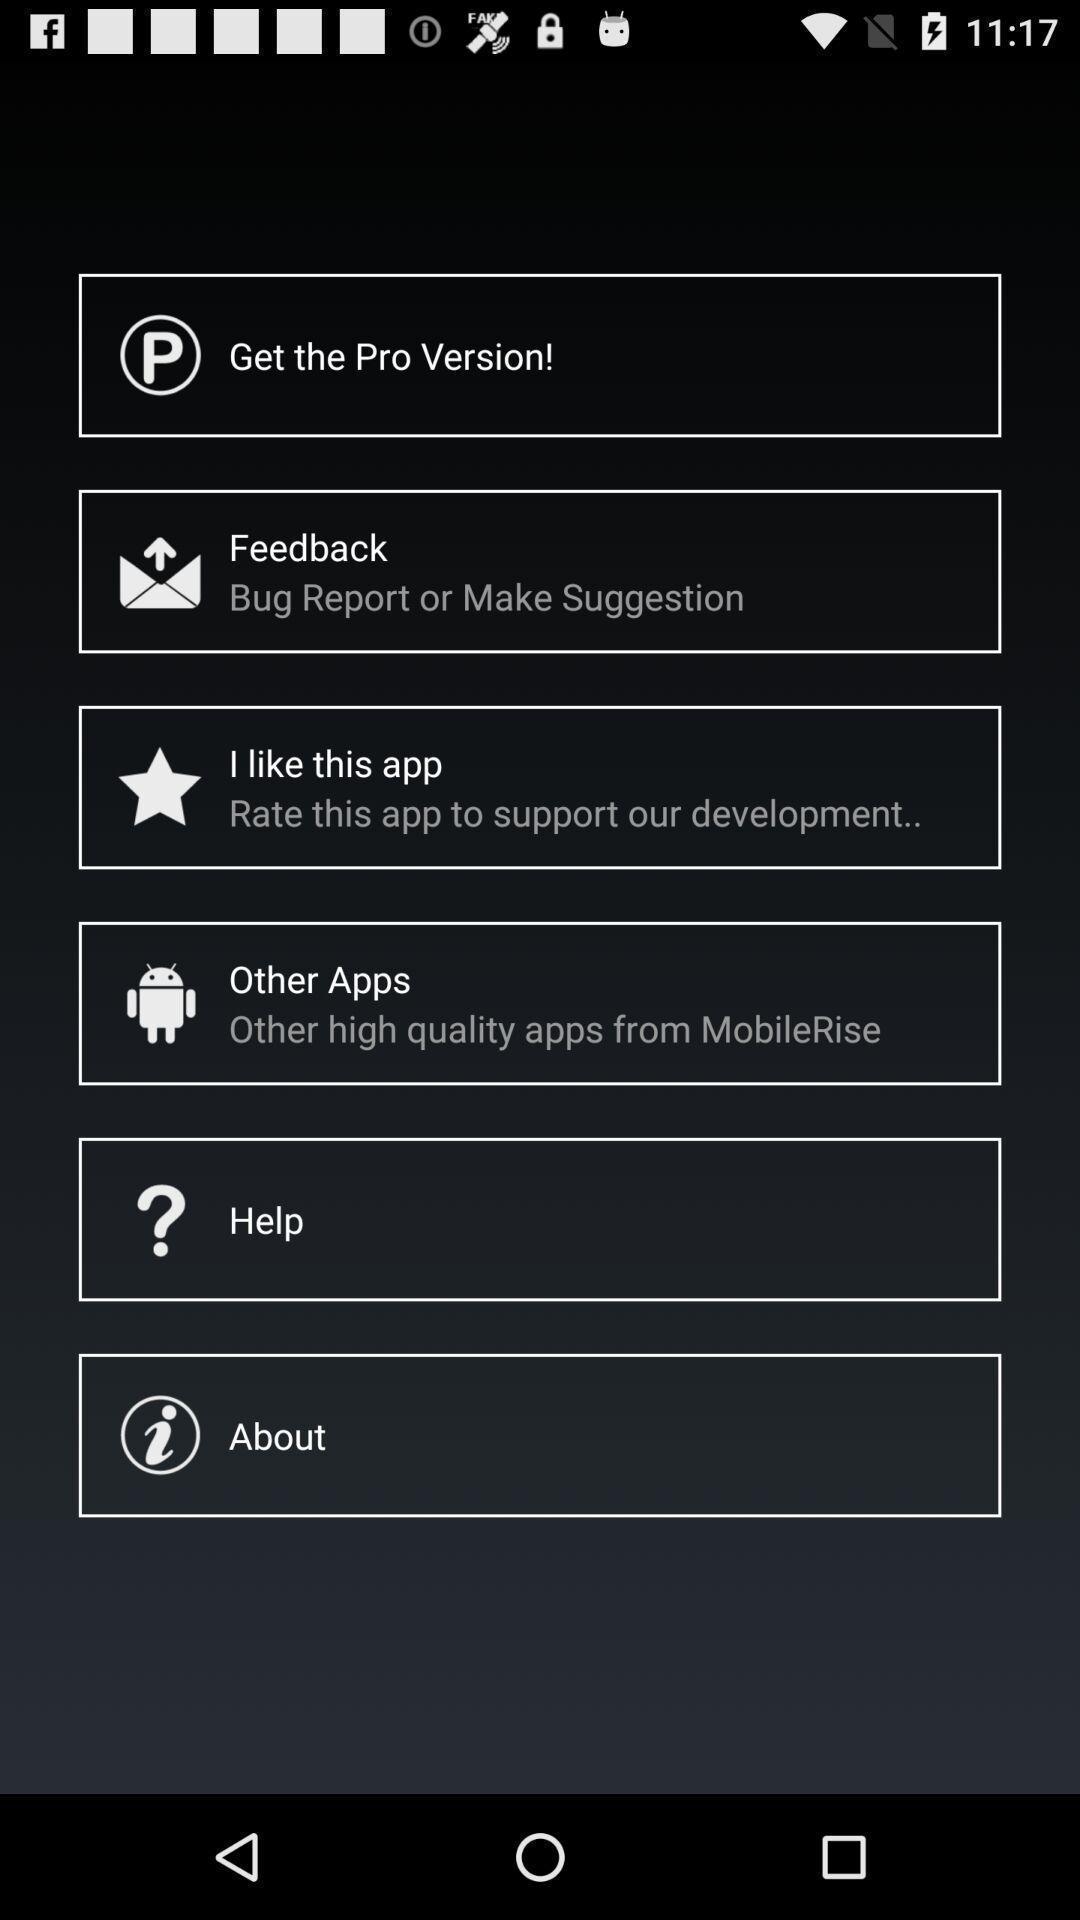Explain the elements present in this screenshot. Menu page of a navigation app. 